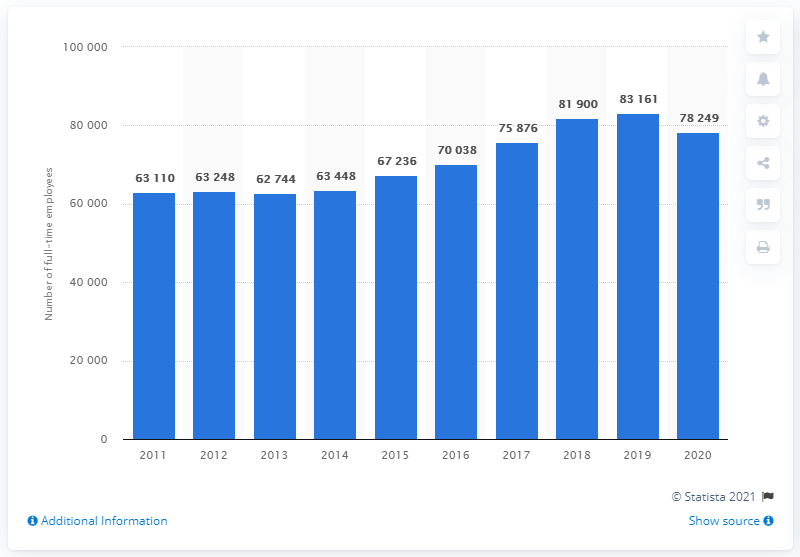Indicate a few pertinent items in this graphic. In 2011, Kuehne + Nagel's last full-time employee was hired. 